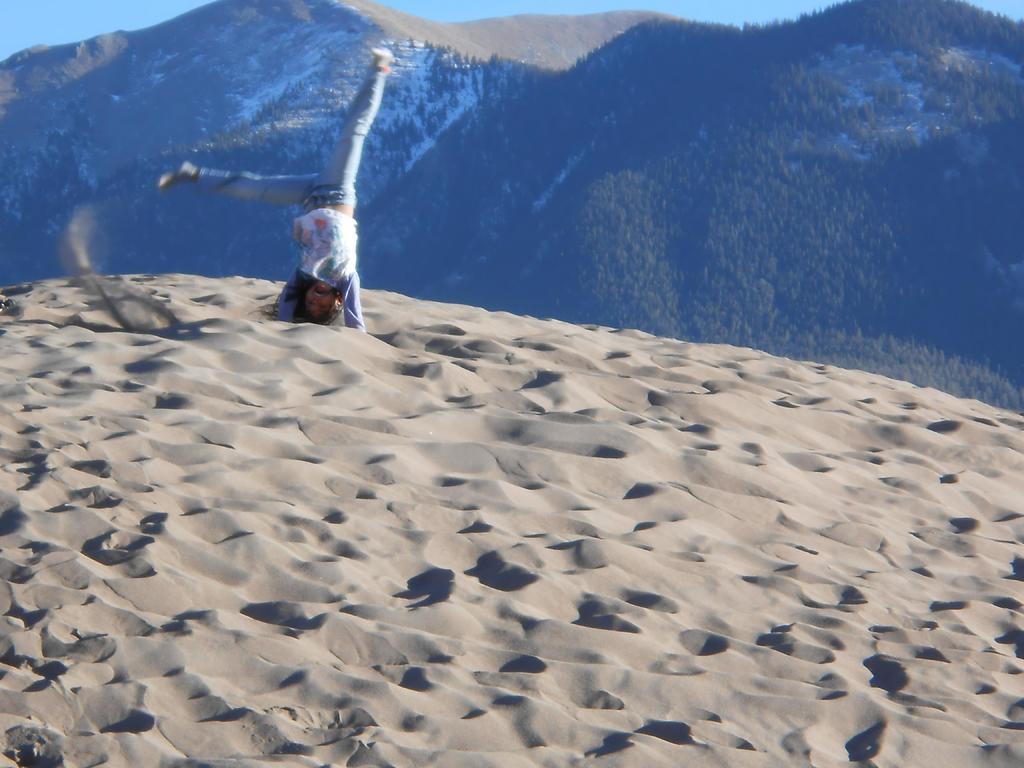Describe this image in one or two sentences. In this image we can see a person. At the bottom there is sand. In the background there are hills and sky. 